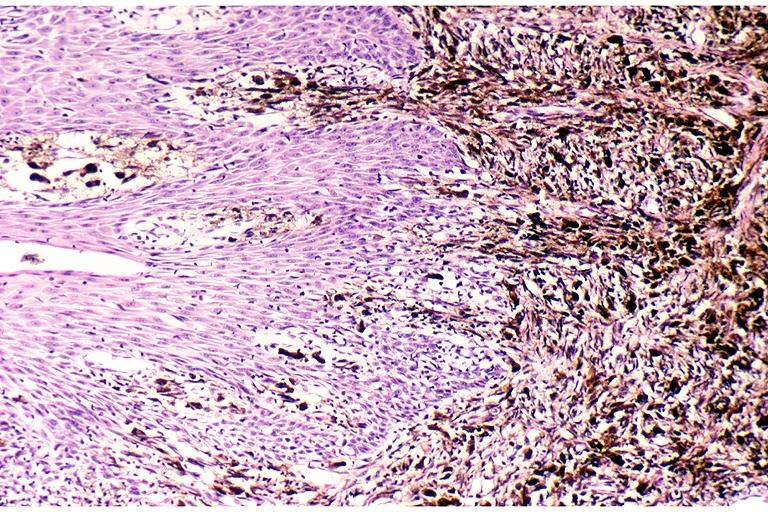what is present?
Answer the question using a single word or phrase. Oral 